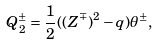Convert formula to latex. <formula><loc_0><loc_0><loc_500><loc_500>Q _ { 2 } ^ { \pm } = \frac { 1 } { 2 } ( ( Z ^ { \mp } ) ^ { 2 } - q ) \theta ^ { \pm } ,</formula> 